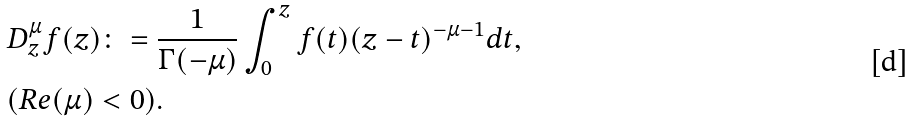<formula> <loc_0><loc_0><loc_500><loc_500>& D _ { z } ^ { \mu } { f ( z ) } \colon = \frac { 1 } { \Gamma ( - \mu ) } \int _ { 0 } ^ { z } f ( t ) ( z - t ) ^ { - \mu - 1 } d t , \\ & ( R e ( \mu ) < 0 ) .</formula> 